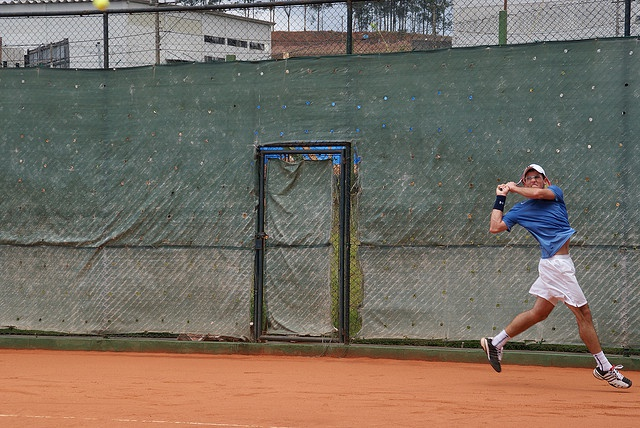Describe the objects in this image and their specific colors. I can see people in lightgray, lavender, maroon, brown, and black tones, tennis racket in lightgray, gray, brown, black, and maroon tones, and sports ball in lightgray, khaki, tan, and olive tones in this image. 